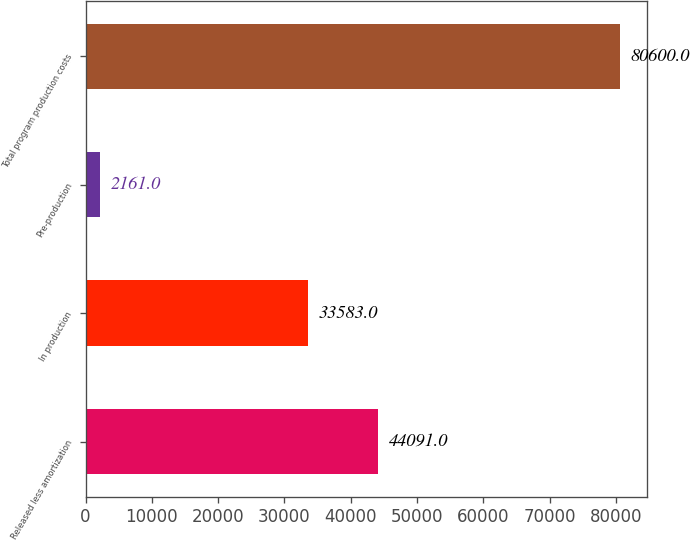<chart> <loc_0><loc_0><loc_500><loc_500><bar_chart><fcel>Released less amortization<fcel>In production<fcel>Pre-production<fcel>Total program production costs<nl><fcel>44091<fcel>33583<fcel>2161<fcel>80600<nl></chart> 